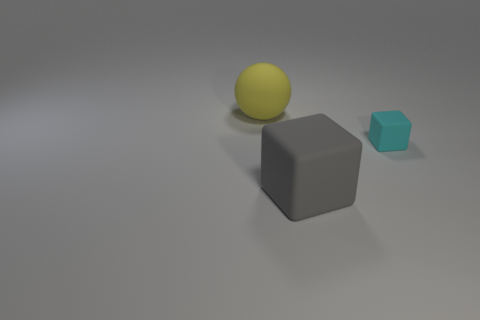Subtract all cyan blocks. How many blocks are left? 1 Add 2 big gray rubber cubes. How many objects exist? 5 Subtract all spheres. How many objects are left? 2 Add 2 big yellow rubber things. How many big yellow rubber things are left? 3 Add 1 matte objects. How many matte objects exist? 4 Subtract 0 yellow blocks. How many objects are left? 3 Subtract all blue balls. Subtract all cyan blocks. How many balls are left? 1 Subtract all yellow cylinders. How many purple balls are left? 0 Subtract all yellow matte spheres. Subtract all yellow rubber objects. How many objects are left? 1 